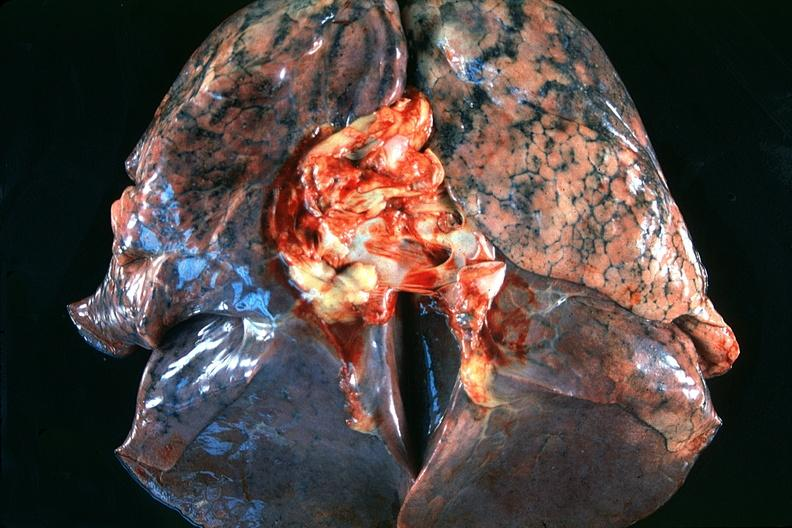what is present?
Answer the question using a single word or phrase. Respiratory 